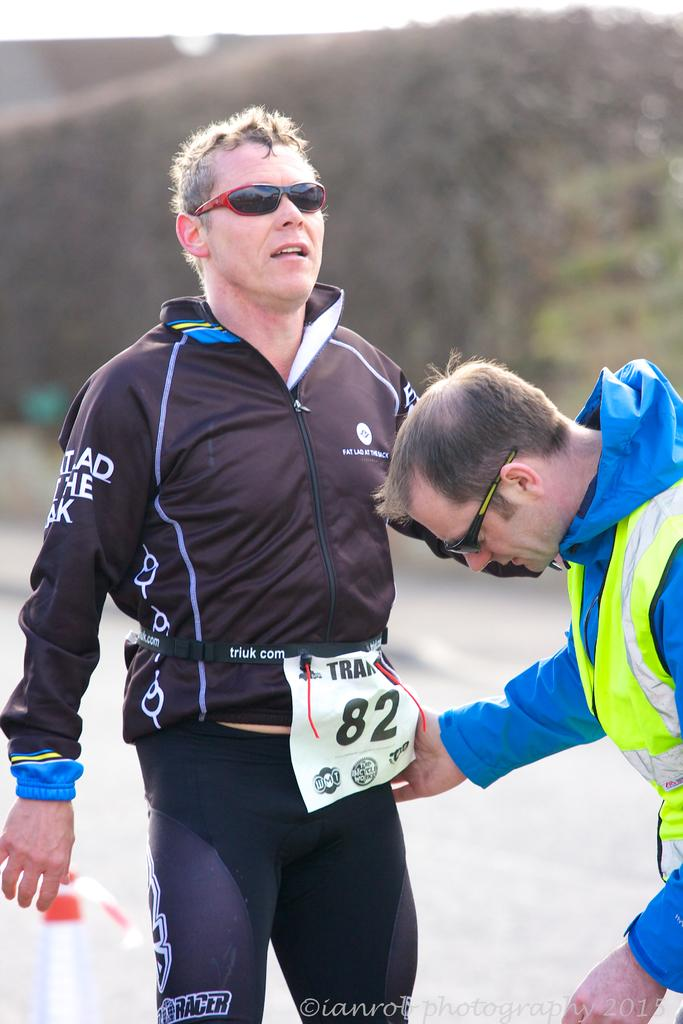<image>
Offer a succinct explanation of the picture presented. A runner in a race wears a tag with his number, 82, on it. 